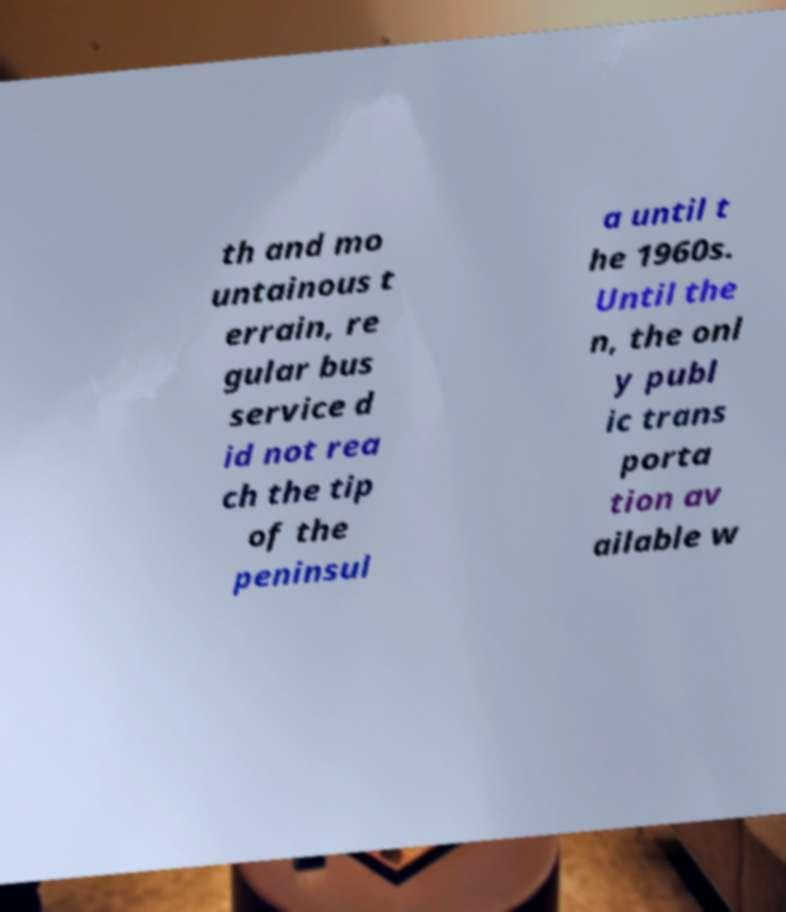For documentation purposes, I need the text within this image transcribed. Could you provide that? th and mo untainous t errain, re gular bus service d id not rea ch the tip of the peninsul a until t he 1960s. Until the n, the onl y publ ic trans porta tion av ailable w 